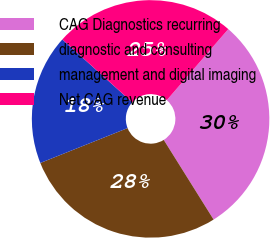Convert chart. <chart><loc_0><loc_0><loc_500><loc_500><pie_chart><fcel>CAG Diagnostics recurring<fcel>diagnostic and consulting<fcel>management and digital imaging<fcel>Net CAG revenue<nl><fcel>29.75%<fcel>27.85%<fcel>17.72%<fcel>24.68%<nl></chart> 